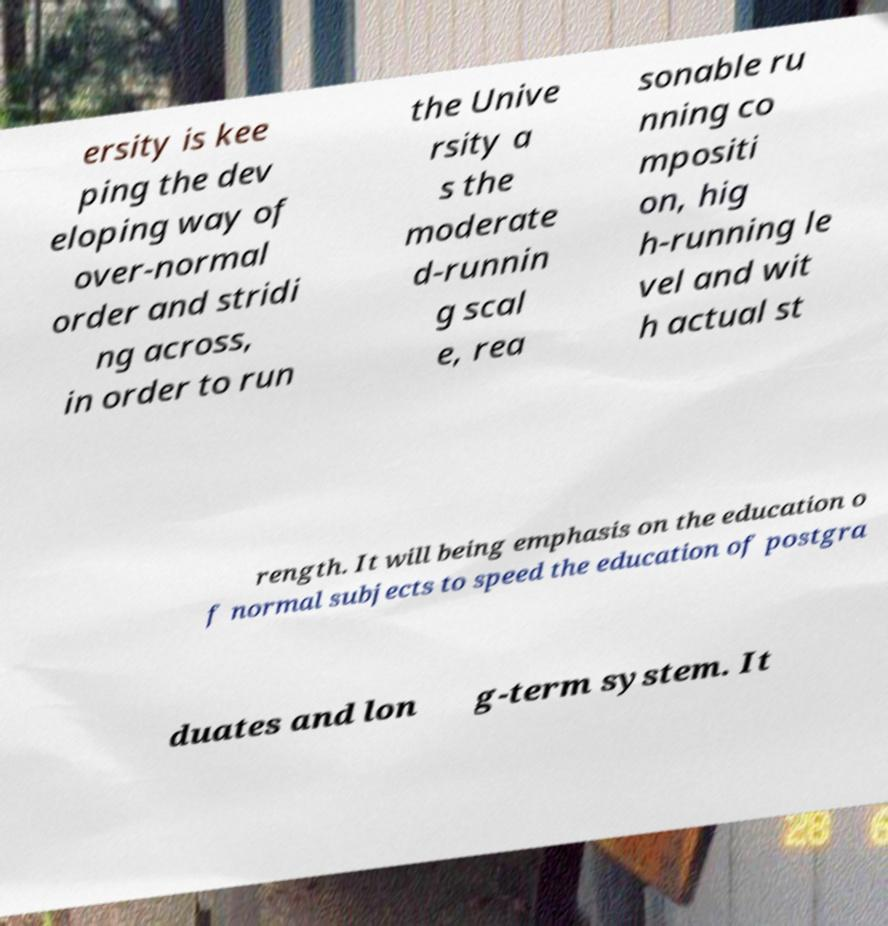There's text embedded in this image that I need extracted. Can you transcribe it verbatim? ersity is kee ping the dev eloping way of over-normal order and stridi ng across, in order to run the Unive rsity a s the moderate d-runnin g scal e, rea sonable ru nning co mpositi on, hig h-running le vel and wit h actual st rength. It will being emphasis on the education o f normal subjects to speed the education of postgra duates and lon g-term system. It 